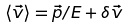<formula> <loc_0><loc_0><loc_500><loc_500>\langle \vec { v } \rangle = \vec { p } / E + \delta \vec { v }</formula> 